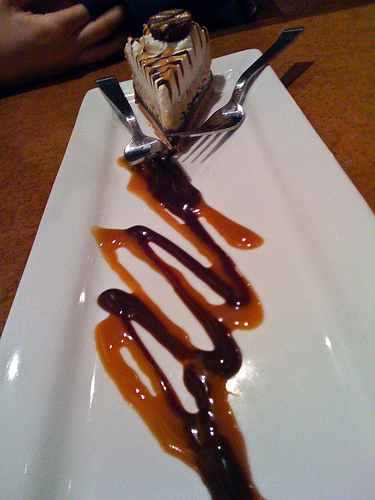<image>
Can you confirm if the chocolate is on the caramel? Yes. Looking at the image, I can see the chocolate is positioned on top of the caramel, with the caramel providing support. 